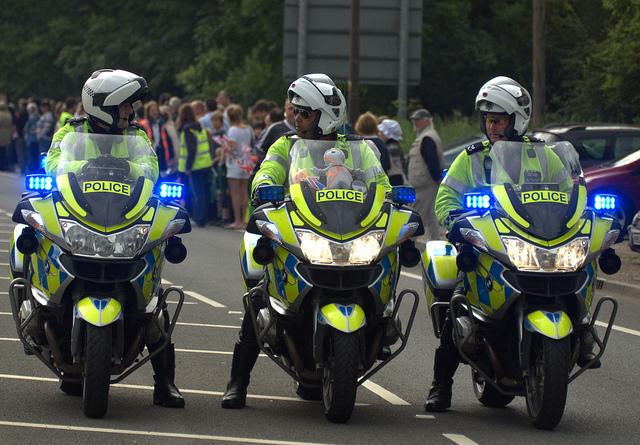How many riders are shown?
Give a very brief answer. 3. Who are riding the bikes?
Concise answer only. Police. What does it say on the front of the bikes?
Give a very brief answer. Police. 